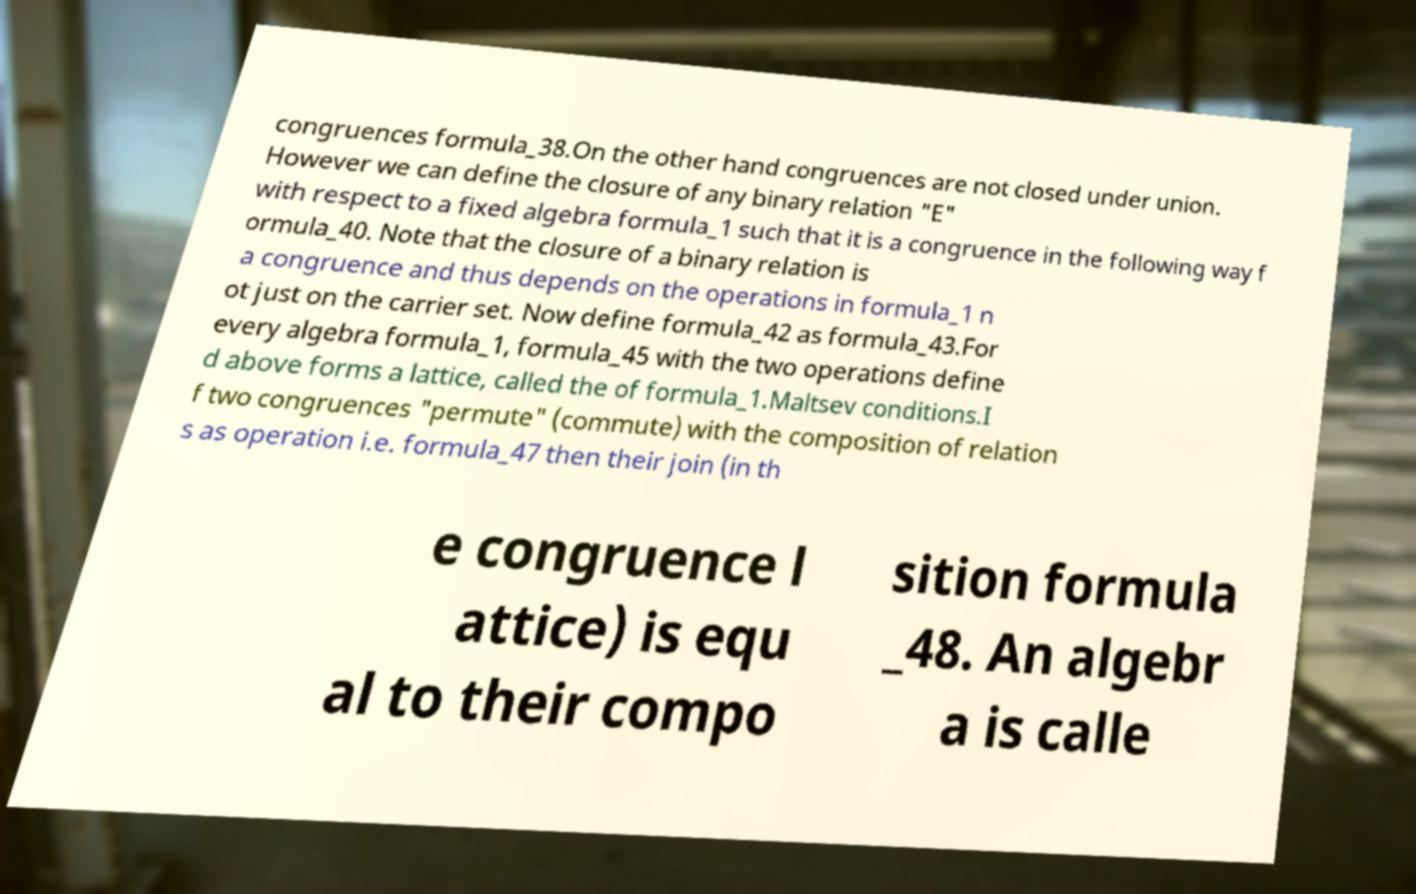Can you read and provide the text displayed in the image?This photo seems to have some interesting text. Can you extract and type it out for me? congruences formula_38.On the other hand congruences are not closed under union. However we can define the closure of any binary relation "E" with respect to a fixed algebra formula_1 such that it is a congruence in the following way f ormula_40. Note that the closure of a binary relation is a congruence and thus depends on the operations in formula_1 n ot just on the carrier set. Now define formula_42 as formula_43.For every algebra formula_1, formula_45 with the two operations define d above forms a lattice, called the of formula_1.Maltsev conditions.I f two congruences "permute" (commute) with the composition of relation s as operation i.e. formula_47 then their join (in th e congruence l attice) is equ al to their compo sition formula _48. An algebr a is calle 